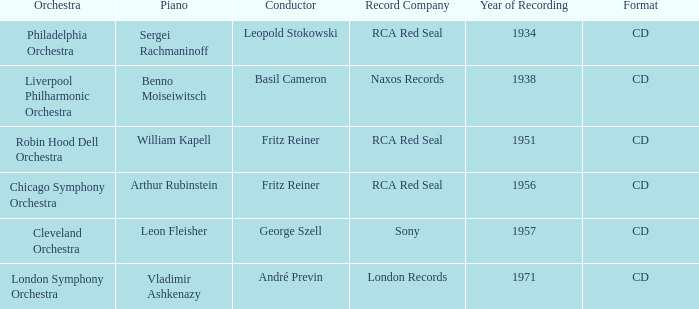Where is the orchestra when the year of recording is 1934? Philadelphia Orchestra. 